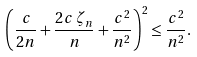Convert formula to latex. <formula><loc_0><loc_0><loc_500><loc_500>\left ( \frac { c } { 2 n } + \frac { 2 c \, \zeta _ { n } } { n } + \frac { c ^ { 2 } } { n ^ { 2 } } \right ) ^ { 2 } \leq \frac { c ^ { 2 } } { n ^ { 2 } } .</formula> 